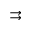Convert formula to latex. <formula><loc_0><loc_0><loc_500><loc_500>\right r i g h t a r r o w s</formula> 